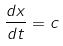<formula> <loc_0><loc_0><loc_500><loc_500>\frac { d x } { d t } = c</formula> 